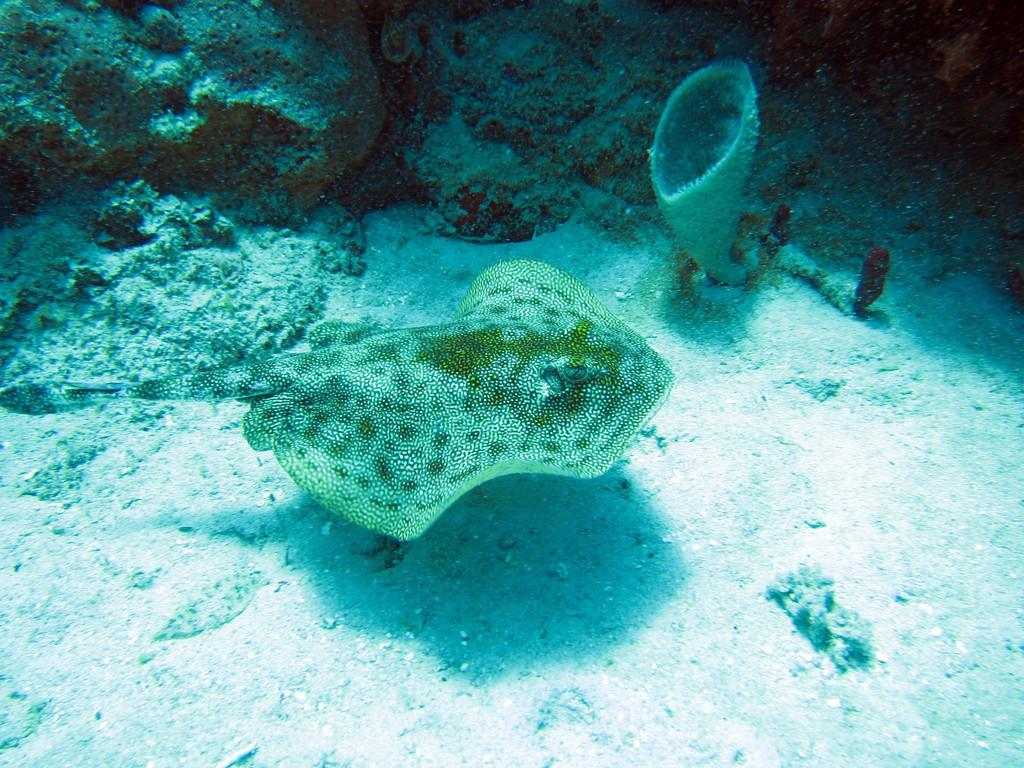Where was the picture taken? The picture was taken in the water. What is the main subject in the center of the image? There is raw fish in the center of the image. What can be seen at the bottom of the image? There is sand at the bottom of the image. What type of underwater environment is visible at the top of the image? There is a coral reef at the top of the image. What type of wound can be seen on the fish in the image? There is no wound visible on the fish in the image; it appears to be raw fish without any injuries. Can you tell me how many drawers are present in the image? There are no drawers present in the image, as it is an underwater scene with raw fish, sand, and coral reef. 